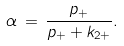<formula> <loc_0><loc_0><loc_500><loc_500>\alpha \, = \, \frac { p _ { + } } { p _ { + } + k _ { 2 + } } .</formula> 